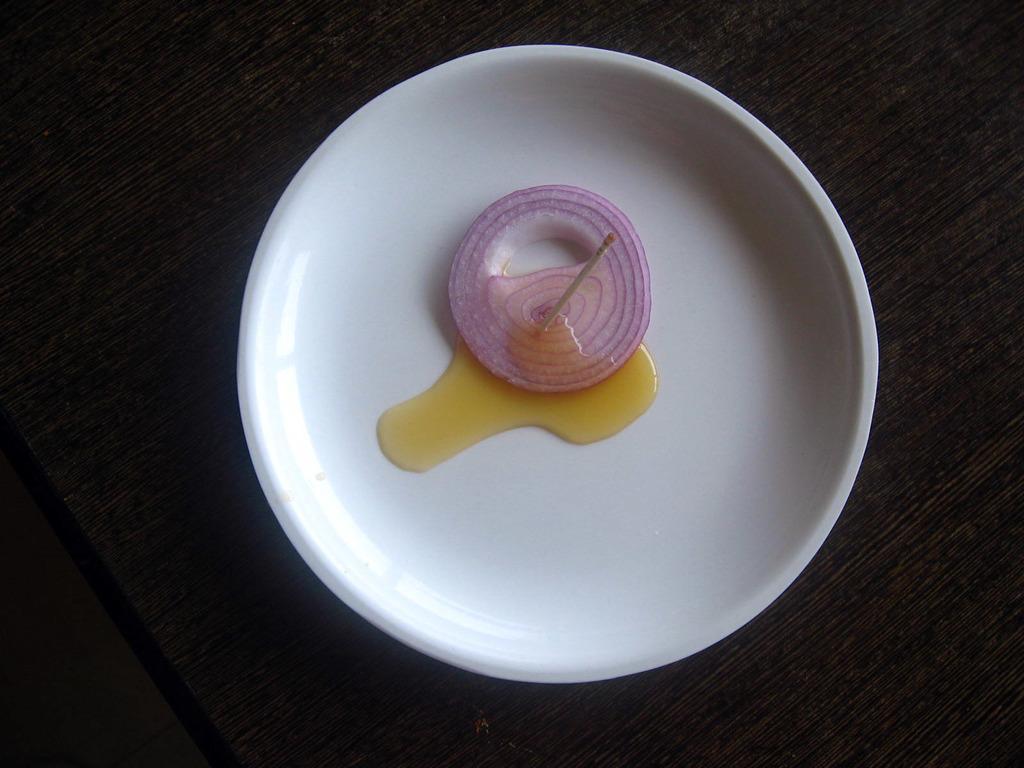Describe this image in one or two sentences. In this image I can see the white color plate on the black color surface. In the plate I can see the onion slice, toothpick and liquid. 